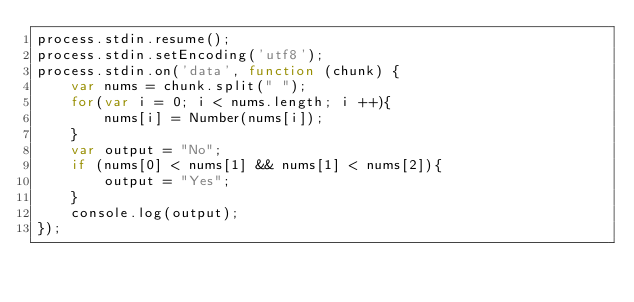Convert code to text. <code><loc_0><loc_0><loc_500><loc_500><_JavaScript_>process.stdin.resume();
process.stdin.setEncoding('utf8');
process.stdin.on('data', function (chunk) {
    var nums = chunk.split(" ");
    for(var i = 0; i < nums.length; i ++){
        nums[i] = Number(nums[i]);
    }
    var output = "No";
    if (nums[0] < nums[1] && nums[1] < nums[2]){
        output = "Yes";
    }
    console.log(output);
});</code> 